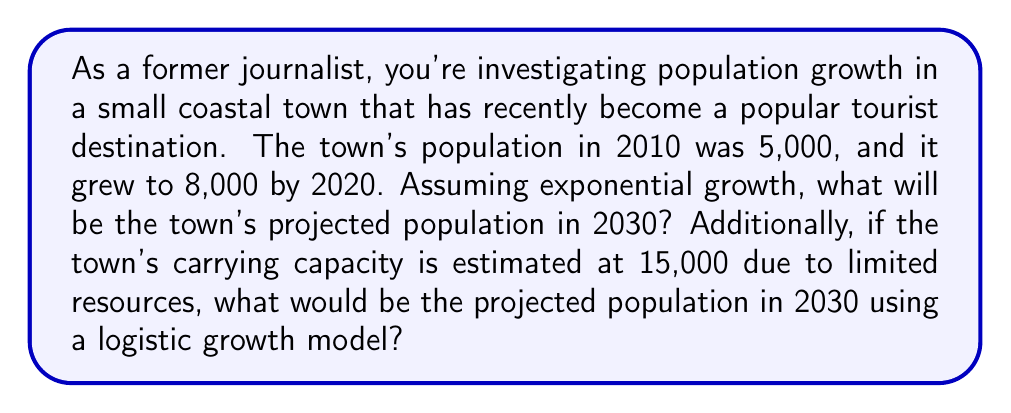What is the answer to this math problem? Let's approach this problem step-by-step:

1. Exponential Growth Model:
   The exponential growth model is given by the equation:
   $$P(t) = P_0 e^{rt}$$
   where $P(t)$ is the population at time $t$, $P_0$ is the initial population, $r$ is the growth rate, and $t$ is the time elapsed.

2. Calculate the growth rate:
   Using the data from 2010 to 2020:
   $$8000 = 5000 e^{10r}$$
   $$\frac{8000}{5000} = e^{10r}$$
   $$\ln(1.6) = 10r$$
   $$r = \frac{\ln(1.6)}{10} \approx 0.0470$$

3. Project population for 2030 using exponential model:
   $$P(20) = 5000 e^{0.0470 \times 20} \approx 12,977$$

4. Logistic Growth Model:
   The logistic growth model is given by the equation:
   $$P(t) = \frac{K}{1 + (\frac{K}{P_0} - 1)e^{-rt}}$$
   where $K$ is the carrying capacity.

5. Project population for 2030 using logistic model:
   $$P(20) = \frac{15000}{1 + (\frac{15000}{5000} - 1)e^{-0.0470 \times 20}} \approx 11,872$$

The logistic model predicts a lower population in 2030 compared to the exponential model, as it accounts for the limiting factors of growth.
Answer: Exponential model: 12,977; Logistic model: 11,872 